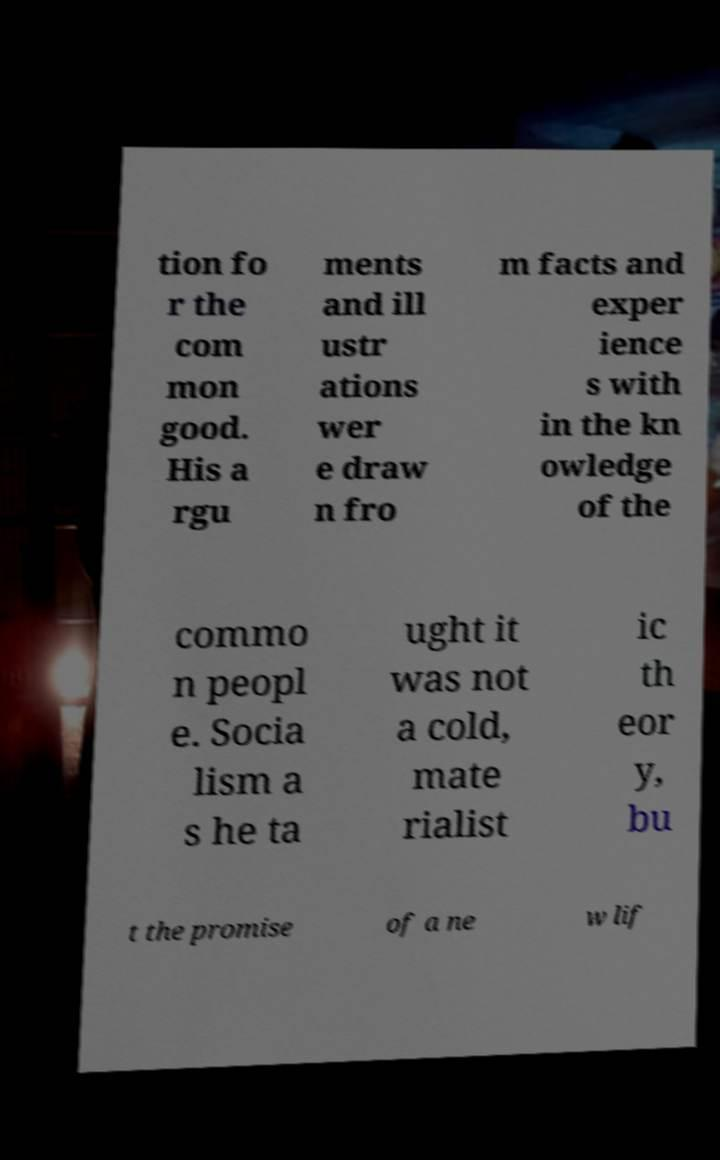I need the written content from this picture converted into text. Can you do that? tion fo r the com mon good. His a rgu ments and ill ustr ations wer e draw n fro m facts and exper ience s with in the kn owledge of the commo n peopl e. Socia lism a s he ta ught it was not a cold, mate rialist ic th eor y, bu t the promise of a ne w lif 